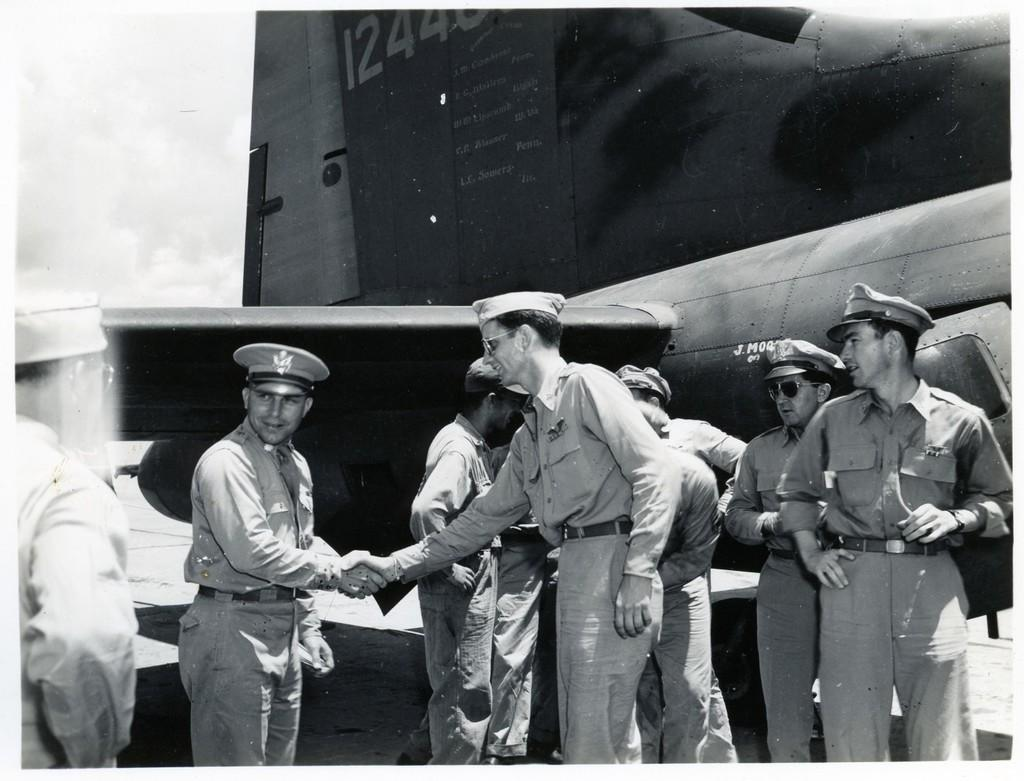<image>
Create a compact narrative representing the image presented. Soldiers are gathered by an aircraft numbered 12440, two shaking hands. 